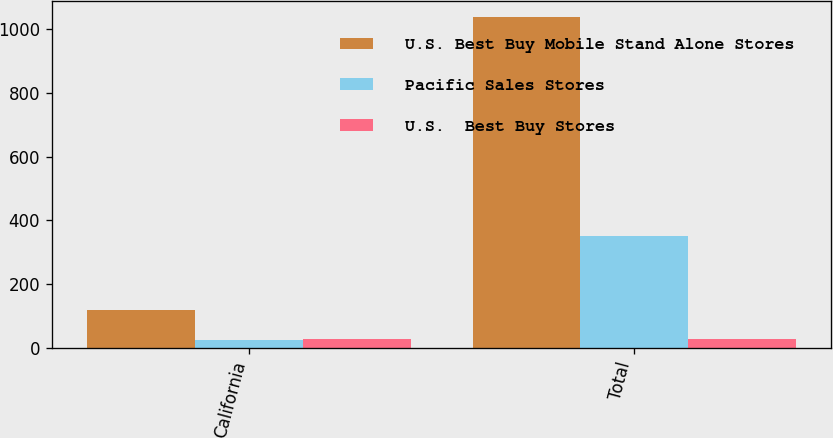<chart> <loc_0><loc_0><loc_500><loc_500><stacked_bar_chart><ecel><fcel>California<fcel>Total<nl><fcel>U.S. Best Buy Mobile Stand Alone Stores<fcel>118<fcel>1037<nl><fcel>Pacific Sales Stores<fcel>26<fcel>350<nl><fcel>U.S.  Best Buy Stores<fcel>28<fcel>28<nl></chart> 